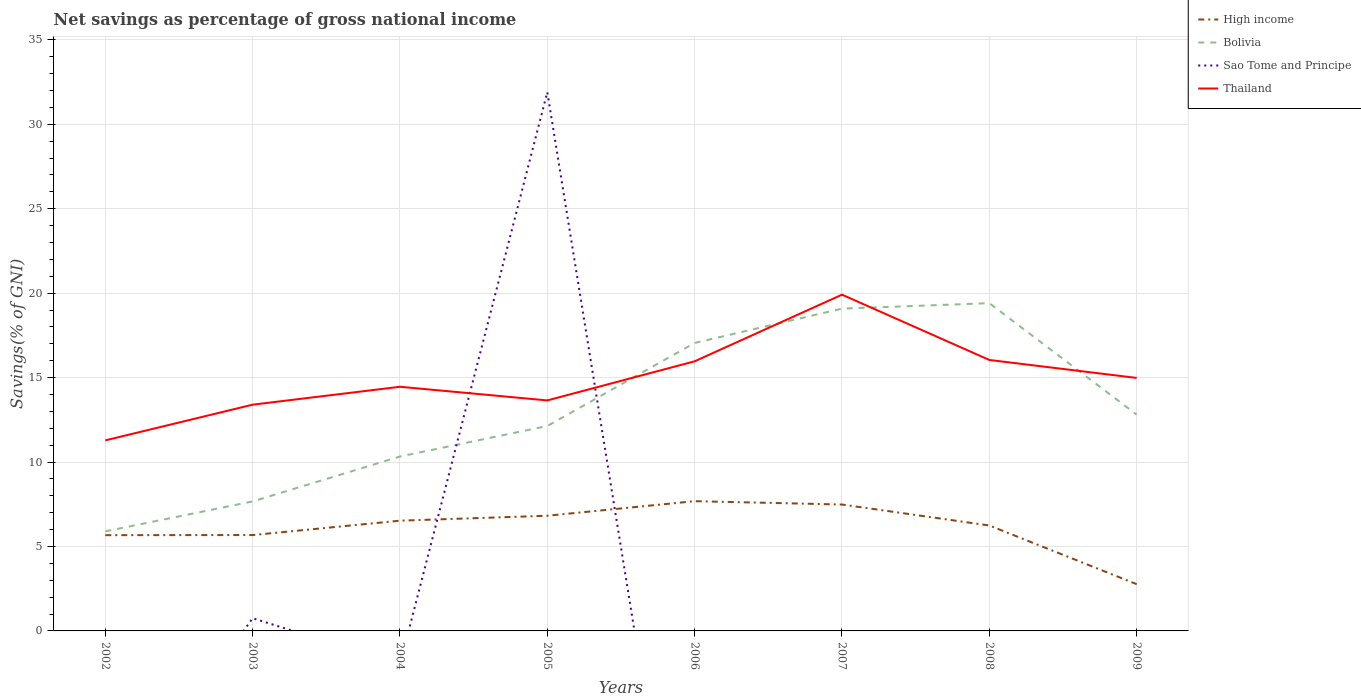How many different coloured lines are there?
Offer a very short reply. 4. Is the number of lines equal to the number of legend labels?
Offer a terse response. No. Across all years, what is the maximum total savings in High income?
Provide a short and direct response. 2.77. What is the total total savings in Bolivia in the graph?
Provide a short and direct response. -0.32. What is the difference between the highest and the second highest total savings in Thailand?
Your answer should be compact. 8.63. Is the total savings in Sao Tome and Principe strictly greater than the total savings in Bolivia over the years?
Provide a succinct answer. No. How many lines are there?
Your answer should be very brief. 4. Where does the legend appear in the graph?
Ensure brevity in your answer.  Top right. What is the title of the graph?
Your response must be concise. Net savings as percentage of gross national income. What is the label or title of the Y-axis?
Offer a very short reply. Savings(% of GNI). What is the Savings(% of GNI) in High income in 2002?
Provide a succinct answer. 5.67. What is the Savings(% of GNI) of Bolivia in 2002?
Your answer should be very brief. 5.9. What is the Savings(% of GNI) of Sao Tome and Principe in 2002?
Offer a terse response. 0. What is the Savings(% of GNI) in Thailand in 2002?
Offer a very short reply. 11.28. What is the Savings(% of GNI) of High income in 2003?
Your answer should be compact. 5.68. What is the Savings(% of GNI) of Bolivia in 2003?
Provide a succinct answer. 7.67. What is the Savings(% of GNI) of Sao Tome and Principe in 2003?
Offer a terse response. 0.75. What is the Savings(% of GNI) in Thailand in 2003?
Your answer should be compact. 13.4. What is the Savings(% of GNI) in High income in 2004?
Give a very brief answer. 6.53. What is the Savings(% of GNI) of Bolivia in 2004?
Provide a succinct answer. 10.33. What is the Savings(% of GNI) of Sao Tome and Principe in 2004?
Give a very brief answer. 0. What is the Savings(% of GNI) in Thailand in 2004?
Ensure brevity in your answer.  14.46. What is the Savings(% of GNI) of High income in 2005?
Your answer should be very brief. 6.82. What is the Savings(% of GNI) in Bolivia in 2005?
Make the answer very short. 12.13. What is the Savings(% of GNI) in Sao Tome and Principe in 2005?
Give a very brief answer. 31.9. What is the Savings(% of GNI) in Thailand in 2005?
Your response must be concise. 13.65. What is the Savings(% of GNI) in High income in 2006?
Your response must be concise. 7.68. What is the Savings(% of GNI) in Bolivia in 2006?
Give a very brief answer. 17.05. What is the Savings(% of GNI) of Thailand in 2006?
Keep it short and to the point. 15.96. What is the Savings(% of GNI) in High income in 2007?
Offer a terse response. 7.48. What is the Savings(% of GNI) of Bolivia in 2007?
Provide a succinct answer. 19.08. What is the Savings(% of GNI) of Sao Tome and Principe in 2007?
Your response must be concise. 0. What is the Savings(% of GNI) in Thailand in 2007?
Keep it short and to the point. 19.91. What is the Savings(% of GNI) in High income in 2008?
Ensure brevity in your answer.  6.24. What is the Savings(% of GNI) of Bolivia in 2008?
Offer a very short reply. 19.41. What is the Savings(% of GNI) in Sao Tome and Principe in 2008?
Make the answer very short. 0. What is the Savings(% of GNI) in Thailand in 2008?
Offer a very short reply. 16.04. What is the Savings(% of GNI) in High income in 2009?
Keep it short and to the point. 2.77. What is the Savings(% of GNI) in Bolivia in 2009?
Provide a short and direct response. 12.81. What is the Savings(% of GNI) of Thailand in 2009?
Give a very brief answer. 14.98. Across all years, what is the maximum Savings(% of GNI) of High income?
Keep it short and to the point. 7.68. Across all years, what is the maximum Savings(% of GNI) of Bolivia?
Keep it short and to the point. 19.41. Across all years, what is the maximum Savings(% of GNI) of Sao Tome and Principe?
Provide a short and direct response. 31.9. Across all years, what is the maximum Savings(% of GNI) of Thailand?
Keep it short and to the point. 19.91. Across all years, what is the minimum Savings(% of GNI) in High income?
Provide a short and direct response. 2.77. Across all years, what is the minimum Savings(% of GNI) in Bolivia?
Keep it short and to the point. 5.9. Across all years, what is the minimum Savings(% of GNI) in Thailand?
Offer a terse response. 11.28. What is the total Savings(% of GNI) of High income in the graph?
Ensure brevity in your answer.  48.87. What is the total Savings(% of GNI) in Bolivia in the graph?
Your answer should be very brief. 104.37. What is the total Savings(% of GNI) in Sao Tome and Principe in the graph?
Provide a succinct answer. 32.65. What is the total Savings(% of GNI) of Thailand in the graph?
Your answer should be very brief. 119.67. What is the difference between the Savings(% of GNI) in High income in 2002 and that in 2003?
Your response must be concise. -0.01. What is the difference between the Savings(% of GNI) of Bolivia in 2002 and that in 2003?
Provide a short and direct response. -1.77. What is the difference between the Savings(% of GNI) of Thailand in 2002 and that in 2003?
Your answer should be compact. -2.11. What is the difference between the Savings(% of GNI) in High income in 2002 and that in 2004?
Provide a succinct answer. -0.86. What is the difference between the Savings(% of GNI) of Bolivia in 2002 and that in 2004?
Make the answer very short. -4.43. What is the difference between the Savings(% of GNI) of Thailand in 2002 and that in 2004?
Your response must be concise. -3.17. What is the difference between the Savings(% of GNI) of High income in 2002 and that in 2005?
Offer a very short reply. -1.15. What is the difference between the Savings(% of GNI) in Bolivia in 2002 and that in 2005?
Offer a terse response. -6.24. What is the difference between the Savings(% of GNI) of Thailand in 2002 and that in 2005?
Give a very brief answer. -2.37. What is the difference between the Savings(% of GNI) in High income in 2002 and that in 2006?
Ensure brevity in your answer.  -2.01. What is the difference between the Savings(% of GNI) in Bolivia in 2002 and that in 2006?
Provide a short and direct response. -11.15. What is the difference between the Savings(% of GNI) in Thailand in 2002 and that in 2006?
Offer a very short reply. -4.68. What is the difference between the Savings(% of GNI) in High income in 2002 and that in 2007?
Your answer should be compact. -1.81. What is the difference between the Savings(% of GNI) of Bolivia in 2002 and that in 2007?
Provide a succinct answer. -13.19. What is the difference between the Savings(% of GNI) of Thailand in 2002 and that in 2007?
Ensure brevity in your answer.  -8.63. What is the difference between the Savings(% of GNI) of High income in 2002 and that in 2008?
Make the answer very short. -0.57. What is the difference between the Savings(% of GNI) in Bolivia in 2002 and that in 2008?
Your answer should be very brief. -13.51. What is the difference between the Savings(% of GNI) in Thailand in 2002 and that in 2008?
Provide a succinct answer. -4.76. What is the difference between the Savings(% of GNI) in High income in 2002 and that in 2009?
Give a very brief answer. 2.9. What is the difference between the Savings(% of GNI) in Bolivia in 2002 and that in 2009?
Keep it short and to the point. -6.91. What is the difference between the Savings(% of GNI) of Thailand in 2002 and that in 2009?
Your answer should be very brief. -3.7. What is the difference between the Savings(% of GNI) in High income in 2003 and that in 2004?
Provide a succinct answer. -0.85. What is the difference between the Savings(% of GNI) in Bolivia in 2003 and that in 2004?
Offer a terse response. -2.66. What is the difference between the Savings(% of GNI) of Thailand in 2003 and that in 2004?
Give a very brief answer. -1.06. What is the difference between the Savings(% of GNI) in High income in 2003 and that in 2005?
Offer a terse response. -1.14. What is the difference between the Savings(% of GNI) of Bolivia in 2003 and that in 2005?
Give a very brief answer. -4.47. What is the difference between the Savings(% of GNI) of Sao Tome and Principe in 2003 and that in 2005?
Give a very brief answer. -31.15. What is the difference between the Savings(% of GNI) of Thailand in 2003 and that in 2005?
Your answer should be compact. -0.25. What is the difference between the Savings(% of GNI) in High income in 2003 and that in 2006?
Keep it short and to the point. -2.01. What is the difference between the Savings(% of GNI) in Bolivia in 2003 and that in 2006?
Provide a short and direct response. -9.38. What is the difference between the Savings(% of GNI) of Thailand in 2003 and that in 2006?
Offer a terse response. -2.57. What is the difference between the Savings(% of GNI) of High income in 2003 and that in 2007?
Your response must be concise. -1.81. What is the difference between the Savings(% of GNI) in Bolivia in 2003 and that in 2007?
Offer a very short reply. -11.42. What is the difference between the Savings(% of GNI) in Thailand in 2003 and that in 2007?
Give a very brief answer. -6.51. What is the difference between the Savings(% of GNI) in High income in 2003 and that in 2008?
Ensure brevity in your answer.  -0.57. What is the difference between the Savings(% of GNI) of Bolivia in 2003 and that in 2008?
Your answer should be compact. -11.74. What is the difference between the Savings(% of GNI) in Thailand in 2003 and that in 2008?
Your answer should be compact. -2.65. What is the difference between the Savings(% of GNI) of High income in 2003 and that in 2009?
Keep it short and to the point. 2.91. What is the difference between the Savings(% of GNI) of Bolivia in 2003 and that in 2009?
Provide a succinct answer. -5.14. What is the difference between the Savings(% of GNI) in Thailand in 2003 and that in 2009?
Ensure brevity in your answer.  -1.58. What is the difference between the Savings(% of GNI) in High income in 2004 and that in 2005?
Keep it short and to the point. -0.29. What is the difference between the Savings(% of GNI) of Bolivia in 2004 and that in 2005?
Give a very brief answer. -1.81. What is the difference between the Savings(% of GNI) of Thailand in 2004 and that in 2005?
Your response must be concise. 0.81. What is the difference between the Savings(% of GNI) of High income in 2004 and that in 2006?
Your response must be concise. -1.15. What is the difference between the Savings(% of GNI) in Bolivia in 2004 and that in 2006?
Keep it short and to the point. -6.72. What is the difference between the Savings(% of GNI) in Thailand in 2004 and that in 2006?
Your answer should be very brief. -1.51. What is the difference between the Savings(% of GNI) of High income in 2004 and that in 2007?
Your response must be concise. -0.96. What is the difference between the Savings(% of GNI) of Bolivia in 2004 and that in 2007?
Your answer should be very brief. -8.76. What is the difference between the Savings(% of GNI) of Thailand in 2004 and that in 2007?
Offer a very short reply. -5.45. What is the difference between the Savings(% of GNI) in High income in 2004 and that in 2008?
Your answer should be very brief. 0.28. What is the difference between the Savings(% of GNI) of Bolivia in 2004 and that in 2008?
Offer a terse response. -9.08. What is the difference between the Savings(% of GNI) of Thailand in 2004 and that in 2008?
Your answer should be very brief. -1.59. What is the difference between the Savings(% of GNI) of High income in 2004 and that in 2009?
Keep it short and to the point. 3.76. What is the difference between the Savings(% of GNI) of Bolivia in 2004 and that in 2009?
Your response must be concise. -2.48. What is the difference between the Savings(% of GNI) in Thailand in 2004 and that in 2009?
Keep it short and to the point. -0.52. What is the difference between the Savings(% of GNI) in High income in 2005 and that in 2006?
Your response must be concise. -0.86. What is the difference between the Savings(% of GNI) in Bolivia in 2005 and that in 2006?
Keep it short and to the point. -4.92. What is the difference between the Savings(% of GNI) in Thailand in 2005 and that in 2006?
Provide a succinct answer. -2.32. What is the difference between the Savings(% of GNI) of High income in 2005 and that in 2007?
Provide a succinct answer. -0.66. What is the difference between the Savings(% of GNI) of Bolivia in 2005 and that in 2007?
Your answer should be very brief. -6.95. What is the difference between the Savings(% of GNI) in Thailand in 2005 and that in 2007?
Offer a terse response. -6.26. What is the difference between the Savings(% of GNI) in High income in 2005 and that in 2008?
Offer a very short reply. 0.58. What is the difference between the Savings(% of GNI) in Bolivia in 2005 and that in 2008?
Your answer should be compact. -7.27. What is the difference between the Savings(% of GNI) in Thailand in 2005 and that in 2008?
Provide a short and direct response. -2.4. What is the difference between the Savings(% of GNI) of High income in 2005 and that in 2009?
Your answer should be compact. 4.05. What is the difference between the Savings(% of GNI) in Bolivia in 2005 and that in 2009?
Your answer should be very brief. -0.67. What is the difference between the Savings(% of GNI) of Thailand in 2005 and that in 2009?
Give a very brief answer. -1.33. What is the difference between the Savings(% of GNI) in High income in 2006 and that in 2007?
Offer a terse response. 0.2. What is the difference between the Savings(% of GNI) in Bolivia in 2006 and that in 2007?
Provide a short and direct response. -2.03. What is the difference between the Savings(% of GNI) in Thailand in 2006 and that in 2007?
Ensure brevity in your answer.  -3.95. What is the difference between the Savings(% of GNI) of High income in 2006 and that in 2008?
Make the answer very short. 1.44. What is the difference between the Savings(% of GNI) of Bolivia in 2006 and that in 2008?
Your response must be concise. -2.35. What is the difference between the Savings(% of GNI) in Thailand in 2006 and that in 2008?
Ensure brevity in your answer.  -0.08. What is the difference between the Savings(% of GNI) in High income in 2006 and that in 2009?
Offer a terse response. 4.91. What is the difference between the Savings(% of GNI) in Bolivia in 2006 and that in 2009?
Provide a short and direct response. 4.24. What is the difference between the Savings(% of GNI) in Thailand in 2006 and that in 2009?
Provide a succinct answer. 0.98. What is the difference between the Savings(% of GNI) in High income in 2007 and that in 2008?
Provide a short and direct response. 1.24. What is the difference between the Savings(% of GNI) of Bolivia in 2007 and that in 2008?
Offer a terse response. -0.32. What is the difference between the Savings(% of GNI) of Thailand in 2007 and that in 2008?
Make the answer very short. 3.87. What is the difference between the Savings(% of GNI) of High income in 2007 and that in 2009?
Ensure brevity in your answer.  4.72. What is the difference between the Savings(% of GNI) of Bolivia in 2007 and that in 2009?
Make the answer very short. 6.28. What is the difference between the Savings(% of GNI) of Thailand in 2007 and that in 2009?
Give a very brief answer. 4.93. What is the difference between the Savings(% of GNI) of High income in 2008 and that in 2009?
Offer a very short reply. 3.47. What is the difference between the Savings(% of GNI) of Bolivia in 2008 and that in 2009?
Provide a succinct answer. 6.6. What is the difference between the Savings(% of GNI) in Thailand in 2008 and that in 2009?
Offer a very short reply. 1.06. What is the difference between the Savings(% of GNI) of High income in 2002 and the Savings(% of GNI) of Bolivia in 2003?
Provide a succinct answer. -2. What is the difference between the Savings(% of GNI) of High income in 2002 and the Savings(% of GNI) of Sao Tome and Principe in 2003?
Offer a very short reply. 4.92. What is the difference between the Savings(% of GNI) of High income in 2002 and the Savings(% of GNI) of Thailand in 2003?
Offer a terse response. -7.73. What is the difference between the Savings(% of GNI) of Bolivia in 2002 and the Savings(% of GNI) of Sao Tome and Principe in 2003?
Provide a succinct answer. 5.14. What is the difference between the Savings(% of GNI) in Bolivia in 2002 and the Savings(% of GNI) in Thailand in 2003?
Provide a short and direct response. -7.5. What is the difference between the Savings(% of GNI) of High income in 2002 and the Savings(% of GNI) of Bolivia in 2004?
Give a very brief answer. -4.66. What is the difference between the Savings(% of GNI) in High income in 2002 and the Savings(% of GNI) in Thailand in 2004?
Keep it short and to the point. -8.79. What is the difference between the Savings(% of GNI) of Bolivia in 2002 and the Savings(% of GNI) of Thailand in 2004?
Your answer should be compact. -8.56. What is the difference between the Savings(% of GNI) in High income in 2002 and the Savings(% of GNI) in Bolivia in 2005?
Your answer should be very brief. -6.46. What is the difference between the Savings(% of GNI) of High income in 2002 and the Savings(% of GNI) of Sao Tome and Principe in 2005?
Your answer should be compact. -26.23. What is the difference between the Savings(% of GNI) in High income in 2002 and the Savings(% of GNI) in Thailand in 2005?
Provide a succinct answer. -7.98. What is the difference between the Savings(% of GNI) of Bolivia in 2002 and the Savings(% of GNI) of Sao Tome and Principe in 2005?
Give a very brief answer. -26. What is the difference between the Savings(% of GNI) of Bolivia in 2002 and the Savings(% of GNI) of Thailand in 2005?
Make the answer very short. -7.75. What is the difference between the Savings(% of GNI) in High income in 2002 and the Savings(% of GNI) in Bolivia in 2006?
Keep it short and to the point. -11.38. What is the difference between the Savings(% of GNI) of High income in 2002 and the Savings(% of GNI) of Thailand in 2006?
Give a very brief answer. -10.29. What is the difference between the Savings(% of GNI) in Bolivia in 2002 and the Savings(% of GNI) in Thailand in 2006?
Your answer should be compact. -10.07. What is the difference between the Savings(% of GNI) in High income in 2002 and the Savings(% of GNI) in Bolivia in 2007?
Make the answer very short. -13.41. What is the difference between the Savings(% of GNI) of High income in 2002 and the Savings(% of GNI) of Thailand in 2007?
Your answer should be very brief. -14.24. What is the difference between the Savings(% of GNI) of Bolivia in 2002 and the Savings(% of GNI) of Thailand in 2007?
Keep it short and to the point. -14.01. What is the difference between the Savings(% of GNI) in High income in 2002 and the Savings(% of GNI) in Bolivia in 2008?
Your answer should be very brief. -13.74. What is the difference between the Savings(% of GNI) of High income in 2002 and the Savings(% of GNI) of Thailand in 2008?
Offer a very short reply. -10.37. What is the difference between the Savings(% of GNI) of Bolivia in 2002 and the Savings(% of GNI) of Thailand in 2008?
Give a very brief answer. -10.15. What is the difference between the Savings(% of GNI) of High income in 2002 and the Savings(% of GNI) of Bolivia in 2009?
Offer a very short reply. -7.14. What is the difference between the Savings(% of GNI) in High income in 2002 and the Savings(% of GNI) in Thailand in 2009?
Provide a short and direct response. -9.31. What is the difference between the Savings(% of GNI) of Bolivia in 2002 and the Savings(% of GNI) of Thailand in 2009?
Keep it short and to the point. -9.08. What is the difference between the Savings(% of GNI) in High income in 2003 and the Savings(% of GNI) in Bolivia in 2004?
Your answer should be very brief. -4.65. What is the difference between the Savings(% of GNI) in High income in 2003 and the Savings(% of GNI) in Thailand in 2004?
Make the answer very short. -8.78. What is the difference between the Savings(% of GNI) of Bolivia in 2003 and the Savings(% of GNI) of Thailand in 2004?
Your response must be concise. -6.79. What is the difference between the Savings(% of GNI) in Sao Tome and Principe in 2003 and the Savings(% of GNI) in Thailand in 2004?
Provide a short and direct response. -13.7. What is the difference between the Savings(% of GNI) in High income in 2003 and the Savings(% of GNI) in Bolivia in 2005?
Your answer should be very brief. -6.46. What is the difference between the Savings(% of GNI) in High income in 2003 and the Savings(% of GNI) in Sao Tome and Principe in 2005?
Make the answer very short. -26.22. What is the difference between the Savings(% of GNI) of High income in 2003 and the Savings(% of GNI) of Thailand in 2005?
Offer a terse response. -7.97. What is the difference between the Savings(% of GNI) in Bolivia in 2003 and the Savings(% of GNI) in Sao Tome and Principe in 2005?
Give a very brief answer. -24.23. What is the difference between the Savings(% of GNI) of Bolivia in 2003 and the Savings(% of GNI) of Thailand in 2005?
Provide a short and direct response. -5.98. What is the difference between the Savings(% of GNI) of Sao Tome and Principe in 2003 and the Savings(% of GNI) of Thailand in 2005?
Provide a short and direct response. -12.89. What is the difference between the Savings(% of GNI) of High income in 2003 and the Savings(% of GNI) of Bolivia in 2006?
Provide a short and direct response. -11.37. What is the difference between the Savings(% of GNI) of High income in 2003 and the Savings(% of GNI) of Thailand in 2006?
Ensure brevity in your answer.  -10.29. What is the difference between the Savings(% of GNI) in Bolivia in 2003 and the Savings(% of GNI) in Thailand in 2006?
Keep it short and to the point. -8.3. What is the difference between the Savings(% of GNI) of Sao Tome and Principe in 2003 and the Savings(% of GNI) of Thailand in 2006?
Your answer should be very brief. -15.21. What is the difference between the Savings(% of GNI) of High income in 2003 and the Savings(% of GNI) of Bolivia in 2007?
Offer a terse response. -13.41. What is the difference between the Savings(% of GNI) in High income in 2003 and the Savings(% of GNI) in Thailand in 2007?
Provide a succinct answer. -14.23. What is the difference between the Savings(% of GNI) of Bolivia in 2003 and the Savings(% of GNI) of Thailand in 2007?
Ensure brevity in your answer.  -12.24. What is the difference between the Savings(% of GNI) of Sao Tome and Principe in 2003 and the Savings(% of GNI) of Thailand in 2007?
Keep it short and to the point. -19.16. What is the difference between the Savings(% of GNI) in High income in 2003 and the Savings(% of GNI) in Bolivia in 2008?
Keep it short and to the point. -13.73. What is the difference between the Savings(% of GNI) of High income in 2003 and the Savings(% of GNI) of Thailand in 2008?
Your answer should be very brief. -10.37. What is the difference between the Savings(% of GNI) in Bolivia in 2003 and the Savings(% of GNI) in Thailand in 2008?
Provide a short and direct response. -8.38. What is the difference between the Savings(% of GNI) in Sao Tome and Principe in 2003 and the Savings(% of GNI) in Thailand in 2008?
Your response must be concise. -15.29. What is the difference between the Savings(% of GNI) in High income in 2003 and the Savings(% of GNI) in Bolivia in 2009?
Provide a short and direct response. -7.13. What is the difference between the Savings(% of GNI) of High income in 2003 and the Savings(% of GNI) of Thailand in 2009?
Offer a very short reply. -9.3. What is the difference between the Savings(% of GNI) of Bolivia in 2003 and the Savings(% of GNI) of Thailand in 2009?
Make the answer very short. -7.31. What is the difference between the Savings(% of GNI) in Sao Tome and Principe in 2003 and the Savings(% of GNI) in Thailand in 2009?
Give a very brief answer. -14.23. What is the difference between the Savings(% of GNI) in High income in 2004 and the Savings(% of GNI) in Bolivia in 2005?
Your answer should be very brief. -5.61. What is the difference between the Savings(% of GNI) in High income in 2004 and the Savings(% of GNI) in Sao Tome and Principe in 2005?
Make the answer very short. -25.37. What is the difference between the Savings(% of GNI) in High income in 2004 and the Savings(% of GNI) in Thailand in 2005?
Offer a very short reply. -7.12. What is the difference between the Savings(% of GNI) in Bolivia in 2004 and the Savings(% of GNI) in Sao Tome and Principe in 2005?
Offer a very short reply. -21.57. What is the difference between the Savings(% of GNI) in Bolivia in 2004 and the Savings(% of GNI) in Thailand in 2005?
Provide a succinct answer. -3.32. What is the difference between the Savings(% of GNI) of High income in 2004 and the Savings(% of GNI) of Bolivia in 2006?
Your response must be concise. -10.52. What is the difference between the Savings(% of GNI) in High income in 2004 and the Savings(% of GNI) in Thailand in 2006?
Ensure brevity in your answer.  -9.44. What is the difference between the Savings(% of GNI) in Bolivia in 2004 and the Savings(% of GNI) in Thailand in 2006?
Ensure brevity in your answer.  -5.64. What is the difference between the Savings(% of GNI) in High income in 2004 and the Savings(% of GNI) in Bolivia in 2007?
Ensure brevity in your answer.  -12.55. What is the difference between the Savings(% of GNI) of High income in 2004 and the Savings(% of GNI) of Thailand in 2007?
Keep it short and to the point. -13.38. What is the difference between the Savings(% of GNI) in Bolivia in 2004 and the Savings(% of GNI) in Thailand in 2007?
Your answer should be compact. -9.58. What is the difference between the Savings(% of GNI) in High income in 2004 and the Savings(% of GNI) in Bolivia in 2008?
Ensure brevity in your answer.  -12.88. What is the difference between the Savings(% of GNI) of High income in 2004 and the Savings(% of GNI) of Thailand in 2008?
Your answer should be compact. -9.52. What is the difference between the Savings(% of GNI) of Bolivia in 2004 and the Savings(% of GNI) of Thailand in 2008?
Your response must be concise. -5.72. What is the difference between the Savings(% of GNI) of High income in 2004 and the Savings(% of GNI) of Bolivia in 2009?
Provide a short and direct response. -6.28. What is the difference between the Savings(% of GNI) of High income in 2004 and the Savings(% of GNI) of Thailand in 2009?
Your response must be concise. -8.45. What is the difference between the Savings(% of GNI) in Bolivia in 2004 and the Savings(% of GNI) in Thailand in 2009?
Offer a terse response. -4.65. What is the difference between the Savings(% of GNI) of High income in 2005 and the Savings(% of GNI) of Bolivia in 2006?
Offer a terse response. -10.23. What is the difference between the Savings(% of GNI) in High income in 2005 and the Savings(% of GNI) in Thailand in 2006?
Keep it short and to the point. -9.14. What is the difference between the Savings(% of GNI) of Bolivia in 2005 and the Savings(% of GNI) of Thailand in 2006?
Give a very brief answer. -3.83. What is the difference between the Savings(% of GNI) of Sao Tome and Principe in 2005 and the Savings(% of GNI) of Thailand in 2006?
Keep it short and to the point. 15.94. What is the difference between the Savings(% of GNI) in High income in 2005 and the Savings(% of GNI) in Bolivia in 2007?
Offer a very short reply. -12.26. What is the difference between the Savings(% of GNI) in High income in 2005 and the Savings(% of GNI) in Thailand in 2007?
Make the answer very short. -13.09. What is the difference between the Savings(% of GNI) in Bolivia in 2005 and the Savings(% of GNI) in Thailand in 2007?
Provide a short and direct response. -7.78. What is the difference between the Savings(% of GNI) of Sao Tome and Principe in 2005 and the Savings(% of GNI) of Thailand in 2007?
Your answer should be compact. 11.99. What is the difference between the Savings(% of GNI) of High income in 2005 and the Savings(% of GNI) of Bolivia in 2008?
Your answer should be compact. -12.59. What is the difference between the Savings(% of GNI) in High income in 2005 and the Savings(% of GNI) in Thailand in 2008?
Give a very brief answer. -9.22. What is the difference between the Savings(% of GNI) of Bolivia in 2005 and the Savings(% of GNI) of Thailand in 2008?
Your answer should be very brief. -3.91. What is the difference between the Savings(% of GNI) of Sao Tome and Principe in 2005 and the Savings(% of GNI) of Thailand in 2008?
Keep it short and to the point. 15.86. What is the difference between the Savings(% of GNI) of High income in 2005 and the Savings(% of GNI) of Bolivia in 2009?
Give a very brief answer. -5.99. What is the difference between the Savings(% of GNI) in High income in 2005 and the Savings(% of GNI) in Thailand in 2009?
Provide a short and direct response. -8.16. What is the difference between the Savings(% of GNI) of Bolivia in 2005 and the Savings(% of GNI) of Thailand in 2009?
Offer a terse response. -2.85. What is the difference between the Savings(% of GNI) of Sao Tome and Principe in 2005 and the Savings(% of GNI) of Thailand in 2009?
Your answer should be compact. 16.92. What is the difference between the Savings(% of GNI) of High income in 2006 and the Savings(% of GNI) of Thailand in 2007?
Provide a short and direct response. -12.23. What is the difference between the Savings(% of GNI) in Bolivia in 2006 and the Savings(% of GNI) in Thailand in 2007?
Provide a succinct answer. -2.86. What is the difference between the Savings(% of GNI) in High income in 2006 and the Savings(% of GNI) in Bolivia in 2008?
Keep it short and to the point. -11.72. What is the difference between the Savings(% of GNI) in High income in 2006 and the Savings(% of GNI) in Thailand in 2008?
Your answer should be very brief. -8.36. What is the difference between the Savings(% of GNI) in Bolivia in 2006 and the Savings(% of GNI) in Thailand in 2008?
Provide a succinct answer. 1.01. What is the difference between the Savings(% of GNI) of High income in 2006 and the Savings(% of GNI) of Bolivia in 2009?
Your answer should be compact. -5.12. What is the difference between the Savings(% of GNI) of High income in 2006 and the Savings(% of GNI) of Thailand in 2009?
Provide a short and direct response. -7.3. What is the difference between the Savings(% of GNI) of Bolivia in 2006 and the Savings(% of GNI) of Thailand in 2009?
Your answer should be very brief. 2.07. What is the difference between the Savings(% of GNI) in High income in 2007 and the Savings(% of GNI) in Bolivia in 2008?
Offer a very short reply. -11.92. What is the difference between the Savings(% of GNI) of High income in 2007 and the Savings(% of GNI) of Thailand in 2008?
Ensure brevity in your answer.  -8.56. What is the difference between the Savings(% of GNI) of Bolivia in 2007 and the Savings(% of GNI) of Thailand in 2008?
Your answer should be very brief. 3.04. What is the difference between the Savings(% of GNI) of High income in 2007 and the Savings(% of GNI) of Bolivia in 2009?
Offer a terse response. -5.32. What is the difference between the Savings(% of GNI) of High income in 2007 and the Savings(% of GNI) of Thailand in 2009?
Give a very brief answer. -7.49. What is the difference between the Savings(% of GNI) in Bolivia in 2007 and the Savings(% of GNI) in Thailand in 2009?
Your response must be concise. 4.1. What is the difference between the Savings(% of GNI) of High income in 2008 and the Savings(% of GNI) of Bolivia in 2009?
Make the answer very short. -6.56. What is the difference between the Savings(% of GNI) of High income in 2008 and the Savings(% of GNI) of Thailand in 2009?
Your answer should be compact. -8.74. What is the difference between the Savings(% of GNI) of Bolivia in 2008 and the Savings(% of GNI) of Thailand in 2009?
Your answer should be compact. 4.43. What is the average Savings(% of GNI) of High income per year?
Offer a very short reply. 6.11. What is the average Savings(% of GNI) in Bolivia per year?
Offer a very short reply. 13.05. What is the average Savings(% of GNI) in Sao Tome and Principe per year?
Provide a short and direct response. 4.08. What is the average Savings(% of GNI) in Thailand per year?
Your answer should be compact. 14.96. In the year 2002, what is the difference between the Savings(% of GNI) of High income and Savings(% of GNI) of Bolivia?
Your response must be concise. -0.23. In the year 2002, what is the difference between the Savings(% of GNI) of High income and Savings(% of GNI) of Thailand?
Make the answer very short. -5.61. In the year 2002, what is the difference between the Savings(% of GNI) in Bolivia and Savings(% of GNI) in Thailand?
Make the answer very short. -5.38. In the year 2003, what is the difference between the Savings(% of GNI) in High income and Savings(% of GNI) in Bolivia?
Your answer should be compact. -1.99. In the year 2003, what is the difference between the Savings(% of GNI) in High income and Savings(% of GNI) in Sao Tome and Principe?
Offer a very short reply. 4.92. In the year 2003, what is the difference between the Savings(% of GNI) in High income and Savings(% of GNI) in Thailand?
Provide a short and direct response. -7.72. In the year 2003, what is the difference between the Savings(% of GNI) of Bolivia and Savings(% of GNI) of Sao Tome and Principe?
Offer a terse response. 6.91. In the year 2003, what is the difference between the Savings(% of GNI) of Bolivia and Savings(% of GNI) of Thailand?
Ensure brevity in your answer.  -5.73. In the year 2003, what is the difference between the Savings(% of GNI) in Sao Tome and Principe and Savings(% of GNI) in Thailand?
Offer a very short reply. -12.64. In the year 2004, what is the difference between the Savings(% of GNI) of High income and Savings(% of GNI) of Bolivia?
Provide a succinct answer. -3.8. In the year 2004, what is the difference between the Savings(% of GNI) in High income and Savings(% of GNI) in Thailand?
Offer a very short reply. -7.93. In the year 2004, what is the difference between the Savings(% of GNI) in Bolivia and Savings(% of GNI) in Thailand?
Ensure brevity in your answer.  -4.13. In the year 2005, what is the difference between the Savings(% of GNI) of High income and Savings(% of GNI) of Bolivia?
Your answer should be compact. -5.31. In the year 2005, what is the difference between the Savings(% of GNI) of High income and Savings(% of GNI) of Sao Tome and Principe?
Your answer should be very brief. -25.08. In the year 2005, what is the difference between the Savings(% of GNI) of High income and Savings(% of GNI) of Thailand?
Provide a succinct answer. -6.83. In the year 2005, what is the difference between the Savings(% of GNI) of Bolivia and Savings(% of GNI) of Sao Tome and Principe?
Your answer should be very brief. -19.77. In the year 2005, what is the difference between the Savings(% of GNI) of Bolivia and Savings(% of GNI) of Thailand?
Make the answer very short. -1.52. In the year 2005, what is the difference between the Savings(% of GNI) of Sao Tome and Principe and Savings(% of GNI) of Thailand?
Give a very brief answer. 18.25. In the year 2006, what is the difference between the Savings(% of GNI) of High income and Savings(% of GNI) of Bolivia?
Keep it short and to the point. -9.37. In the year 2006, what is the difference between the Savings(% of GNI) of High income and Savings(% of GNI) of Thailand?
Keep it short and to the point. -8.28. In the year 2006, what is the difference between the Savings(% of GNI) of Bolivia and Savings(% of GNI) of Thailand?
Offer a very short reply. 1.09. In the year 2007, what is the difference between the Savings(% of GNI) of High income and Savings(% of GNI) of Bolivia?
Provide a succinct answer. -11.6. In the year 2007, what is the difference between the Savings(% of GNI) in High income and Savings(% of GNI) in Thailand?
Ensure brevity in your answer.  -12.42. In the year 2007, what is the difference between the Savings(% of GNI) of Bolivia and Savings(% of GNI) of Thailand?
Provide a short and direct response. -0.83. In the year 2008, what is the difference between the Savings(% of GNI) in High income and Savings(% of GNI) in Bolivia?
Keep it short and to the point. -13.16. In the year 2008, what is the difference between the Savings(% of GNI) of High income and Savings(% of GNI) of Thailand?
Your response must be concise. -9.8. In the year 2008, what is the difference between the Savings(% of GNI) of Bolivia and Savings(% of GNI) of Thailand?
Your answer should be compact. 3.36. In the year 2009, what is the difference between the Savings(% of GNI) of High income and Savings(% of GNI) of Bolivia?
Your answer should be very brief. -10.04. In the year 2009, what is the difference between the Savings(% of GNI) in High income and Savings(% of GNI) in Thailand?
Your answer should be compact. -12.21. In the year 2009, what is the difference between the Savings(% of GNI) of Bolivia and Savings(% of GNI) of Thailand?
Ensure brevity in your answer.  -2.17. What is the ratio of the Savings(% of GNI) of High income in 2002 to that in 2003?
Give a very brief answer. 1. What is the ratio of the Savings(% of GNI) in Bolivia in 2002 to that in 2003?
Give a very brief answer. 0.77. What is the ratio of the Savings(% of GNI) of Thailand in 2002 to that in 2003?
Make the answer very short. 0.84. What is the ratio of the Savings(% of GNI) of High income in 2002 to that in 2004?
Offer a very short reply. 0.87. What is the ratio of the Savings(% of GNI) in Bolivia in 2002 to that in 2004?
Your answer should be compact. 0.57. What is the ratio of the Savings(% of GNI) in Thailand in 2002 to that in 2004?
Offer a terse response. 0.78. What is the ratio of the Savings(% of GNI) of High income in 2002 to that in 2005?
Your response must be concise. 0.83. What is the ratio of the Savings(% of GNI) in Bolivia in 2002 to that in 2005?
Provide a succinct answer. 0.49. What is the ratio of the Savings(% of GNI) in Thailand in 2002 to that in 2005?
Provide a succinct answer. 0.83. What is the ratio of the Savings(% of GNI) of High income in 2002 to that in 2006?
Provide a short and direct response. 0.74. What is the ratio of the Savings(% of GNI) in Bolivia in 2002 to that in 2006?
Offer a terse response. 0.35. What is the ratio of the Savings(% of GNI) of Thailand in 2002 to that in 2006?
Give a very brief answer. 0.71. What is the ratio of the Savings(% of GNI) in High income in 2002 to that in 2007?
Your response must be concise. 0.76. What is the ratio of the Savings(% of GNI) of Bolivia in 2002 to that in 2007?
Make the answer very short. 0.31. What is the ratio of the Savings(% of GNI) in Thailand in 2002 to that in 2007?
Give a very brief answer. 0.57. What is the ratio of the Savings(% of GNI) in High income in 2002 to that in 2008?
Give a very brief answer. 0.91. What is the ratio of the Savings(% of GNI) in Bolivia in 2002 to that in 2008?
Keep it short and to the point. 0.3. What is the ratio of the Savings(% of GNI) of Thailand in 2002 to that in 2008?
Offer a very short reply. 0.7. What is the ratio of the Savings(% of GNI) of High income in 2002 to that in 2009?
Keep it short and to the point. 2.05. What is the ratio of the Savings(% of GNI) in Bolivia in 2002 to that in 2009?
Provide a short and direct response. 0.46. What is the ratio of the Savings(% of GNI) in Thailand in 2002 to that in 2009?
Your answer should be compact. 0.75. What is the ratio of the Savings(% of GNI) in High income in 2003 to that in 2004?
Your response must be concise. 0.87. What is the ratio of the Savings(% of GNI) of Bolivia in 2003 to that in 2004?
Provide a succinct answer. 0.74. What is the ratio of the Savings(% of GNI) of Thailand in 2003 to that in 2004?
Your answer should be compact. 0.93. What is the ratio of the Savings(% of GNI) in High income in 2003 to that in 2005?
Your answer should be compact. 0.83. What is the ratio of the Savings(% of GNI) of Bolivia in 2003 to that in 2005?
Keep it short and to the point. 0.63. What is the ratio of the Savings(% of GNI) in Sao Tome and Principe in 2003 to that in 2005?
Offer a very short reply. 0.02. What is the ratio of the Savings(% of GNI) of Thailand in 2003 to that in 2005?
Provide a short and direct response. 0.98. What is the ratio of the Savings(% of GNI) in High income in 2003 to that in 2006?
Your answer should be compact. 0.74. What is the ratio of the Savings(% of GNI) in Bolivia in 2003 to that in 2006?
Keep it short and to the point. 0.45. What is the ratio of the Savings(% of GNI) in Thailand in 2003 to that in 2006?
Make the answer very short. 0.84. What is the ratio of the Savings(% of GNI) of High income in 2003 to that in 2007?
Your answer should be compact. 0.76. What is the ratio of the Savings(% of GNI) in Bolivia in 2003 to that in 2007?
Offer a terse response. 0.4. What is the ratio of the Savings(% of GNI) of Thailand in 2003 to that in 2007?
Offer a terse response. 0.67. What is the ratio of the Savings(% of GNI) of High income in 2003 to that in 2008?
Provide a short and direct response. 0.91. What is the ratio of the Savings(% of GNI) of Bolivia in 2003 to that in 2008?
Make the answer very short. 0.4. What is the ratio of the Savings(% of GNI) of Thailand in 2003 to that in 2008?
Provide a succinct answer. 0.83. What is the ratio of the Savings(% of GNI) in High income in 2003 to that in 2009?
Your answer should be very brief. 2.05. What is the ratio of the Savings(% of GNI) in Bolivia in 2003 to that in 2009?
Give a very brief answer. 0.6. What is the ratio of the Savings(% of GNI) of Thailand in 2003 to that in 2009?
Offer a terse response. 0.89. What is the ratio of the Savings(% of GNI) in High income in 2004 to that in 2005?
Give a very brief answer. 0.96. What is the ratio of the Savings(% of GNI) of Bolivia in 2004 to that in 2005?
Give a very brief answer. 0.85. What is the ratio of the Savings(% of GNI) in Thailand in 2004 to that in 2005?
Offer a terse response. 1.06. What is the ratio of the Savings(% of GNI) of High income in 2004 to that in 2006?
Offer a very short reply. 0.85. What is the ratio of the Savings(% of GNI) in Bolivia in 2004 to that in 2006?
Keep it short and to the point. 0.61. What is the ratio of the Savings(% of GNI) of Thailand in 2004 to that in 2006?
Give a very brief answer. 0.91. What is the ratio of the Savings(% of GNI) of High income in 2004 to that in 2007?
Make the answer very short. 0.87. What is the ratio of the Savings(% of GNI) in Bolivia in 2004 to that in 2007?
Make the answer very short. 0.54. What is the ratio of the Savings(% of GNI) of Thailand in 2004 to that in 2007?
Ensure brevity in your answer.  0.73. What is the ratio of the Savings(% of GNI) of High income in 2004 to that in 2008?
Give a very brief answer. 1.05. What is the ratio of the Savings(% of GNI) of Bolivia in 2004 to that in 2008?
Provide a succinct answer. 0.53. What is the ratio of the Savings(% of GNI) in Thailand in 2004 to that in 2008?
Your answer should be compact. 0.9. What is the ratio of the Savings(% of GNI) of High income in 2004 to that in 2009?
Make the answer very short. 2.36. What is the ratio of the Savings(% of GNI) in Bolivia in 2004 to that in 2009?
Make the answer very short. 0.81. What is the ratio of the Savings(% of GNI) of Thailand in 2004 to that in 2009?
Make the answer very short. 0.97. What is the ratio of the Savings(% of GNI) of High income in 2005 to that in 2006?
Provide a short and direct response. 0.89. What is the ratio of the Savings(% of GNI) in Bolivia in 2005 to that in 2006?
Offer a very short reply. 0.71. What is the ratio of the Savings(% of GNI) of Thailand in 2005 to that in 2006?
Your answer should be compact. 0.85. What is the ratio of the Savings(% of GNI) in High income in 2005 to that in 2007?
Provide a short and direct response. 0.91. What is the ratio of the Savings(% of GNI) of Bolivia in 2005 to that in 2007?
Your answer should be very brief. 0.64. What is the ratio of the Savings(% of GNI) of Thailand in 2005 to that in 2007?
Your answer should be very brief. 0.69. What is the ratio of the Savings(% of GNI) in High income in 2005 to that in 2008?
Provide a short and direct response. 1.09. What is the ratio of the Savings(% of GNI) in Bolivia in 2005 to that in 2008?
Provide a succinct answer. 0.63. What is the ratio of the Savings(% of GNI) in Thailand in 2005 to that in 2008?
Make the answer very short. 0.85. What is the ratio of the Savings(% of GNI) in High income in 2005 to that in 2009?
Give a very brief answer. 2.46. What is the ratio of the Savings(% of GNI) of Bolivia in 2005 to that in 2009?
Provide a short and direct response. 0.95. What is the ratio of the Savings(% of GNI) in Thailand in 2005 to that in 2009?
Provide a short and direct response. 0.91. What is the ratio of the Savings(% of GNI) in High income in 2006 to that in 2007?
Offer a terse response. 1.03. What is the ratio of the Savings(% of GNI) of Bolivia in 2006 to that in 2007?
Your answer should be compact. 0.89. What is the ratio of the Savings(% of GNI) of Thailand in 2006 to that in 2007?
Your answer should be very brief. 0.8. What is the ratio of the Savings(% of GNI) of High income in 2006 to that in 2008?
Provide a short and direct response. 1.23. What is the ratio of the Savings(% of GNI) of Bolivia in 2006 to that in 2008?
Your response must be concise. 0.88. What is the ratio of the Savings(% of GNI) of High income in 2006 to that in 2009?
Give a very brief answer. 2.77. What is the ratio of the Savings(% of GNI) of Bolivia in 2006 to that in 2009?
Keep it short and to the point. 1.33. What is the ratio of the Savings(% of GNI) in Thailand in 2006 to that in 2009?
Your answer should be very brief. 1.07. What is the ratio of the Savings(% of GNI) of High income in 2007 to that in 2008?
Keep it short and to the point. 1.2. What is the ratio of the Savings(% of GNI) in Bolivia in 2007 to that in 2008?
Your response must be concise. 0.98. What is the ratio of the Savings(% of GNI) in Thailand in 2007 to that in 2008?
Provide a succinct answer. 1.24. What is the ratio of the Savings(% of GNI) of High income in 2007 to that in 2009?
Provide a succinct answer. 2.7. What is the ratio of the Savings(% of GNI) of Bolivia in 2007 to that in 2009?
Provide a succinct answer. 1.49. What is the ratio of the Savings(% of GNI) in Thailand in 2007 to that in 2009?
Your answer should be very brief. 1.33. What is the ratio of the Savings(% of GNI) of High income in 2008 to that in 2009?
Your answer should be compact. 2.25. What is the ratio of the Savings(% of GNI) of Bolivia in 2008 to that in 2009?
Make the answer very short. 1.52. What is the ratio of the Savings(% of GNI) in Thailand in 2008 to that in 2009?
Give a very brief answer. 1.07. What is the difference between the highest and the second highest Savings(% of GNI) in High income?
Offer a terse response. 0.2. What is the difference between the highest and the second highest Savings(% of GNI) in Bolivia?
Your answer should be very brief. 0.32. What is the difference between the highest and the second highest Savings(% of GNI) of Thailand?
Your answer should be very brief. 3.87. What is the difference between the highest and the lowest Savings(% of GNI) of High income?
Ensure brevity in your answer.  4.91. What is the difference between the highest and the lowest Savings(% of GNI) in Bolivia?
Your response must be concise. 13.51. What is the difference between the highest and the lowest Savings(% of GNI) of Sao Tome and Principe?
Make the answer very short. 31.9. What is the difference between the highest and the lowest Savings(% of GNI) of Thailand?
Ensure brevity in your answer.  8.63. 